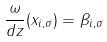<formula> <loc_0><loc_0><loc_500><loc_500>\frac { \omega } { d z } ( x _ { i , \sigma } ) = \beta _ { i , \sigma }</formula> 